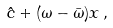Convert formula to latex. <formula><loc_0><loc_0><loc_500><loc_500>\hat { c } + ( \omega - \bar { \omega } ) x \, ,</formula> 